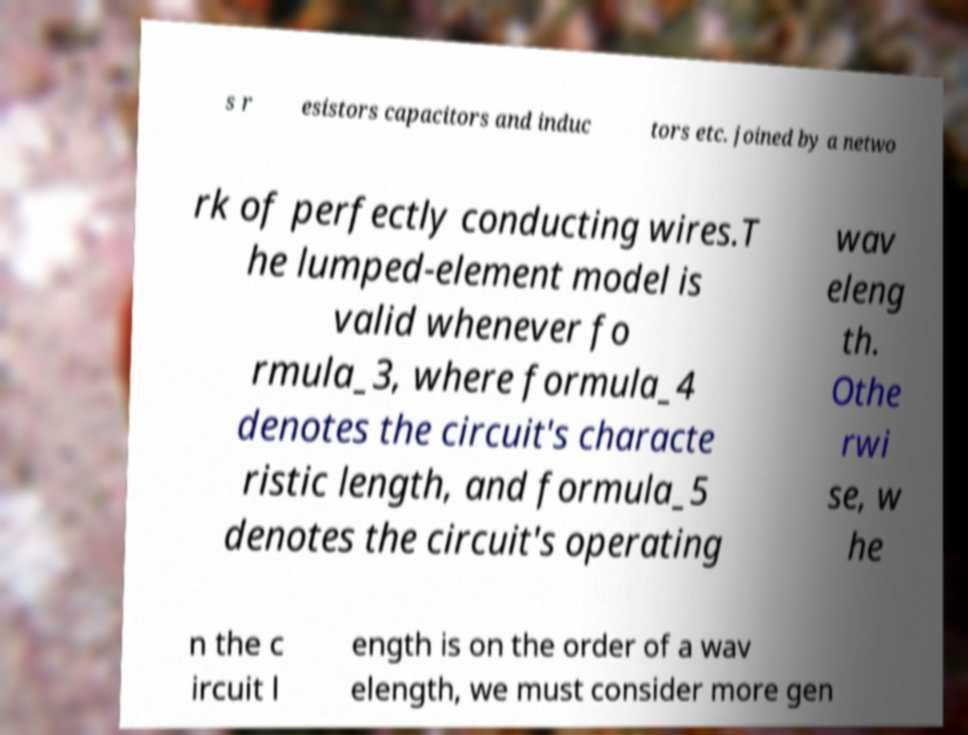I need the written content from this picture converted into text. Can you do that? s r esistors capacitors and induc tors etc. joined by a netwo rk of perfectly conducting wires.T he lumped-element model is valid whenever fo rmula_3, where formula_4 denotes the circuit's characte ristic length, and formula_5 denotes the circuit's operating wav eleng th. Othe rwi se, w he n the c ircuit l ength is on the order of a wav elength, we must consider more gen 